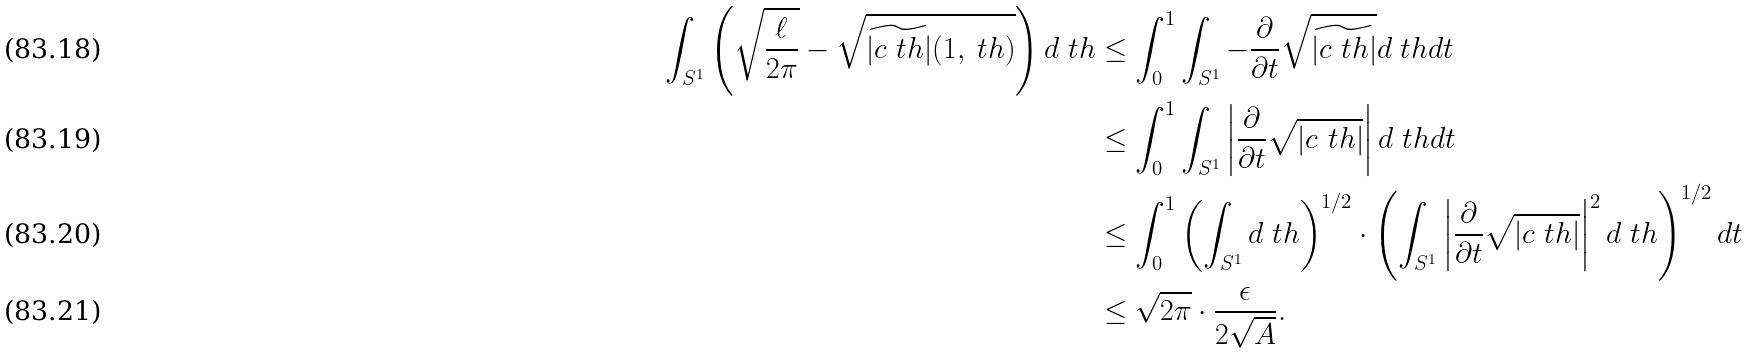Convert formula to latex. <formula><loc_0><loc_0><loc_500><loc_500>\int _ { S ^ { 1 } } \left ( \sqrt { \frac { \ell } { 2 \pi } } - \sqrt { \widetilde { | c _ { \ } t h | } ( 1 , \ t h ) } \right ) d \ t h & \leq \int _ { 0 } ^ { 1 } \int _ { S ^ { 1 } } - \frac { \partial } { \partial t } \sqrt { \widetilde { | c _ { \ } t h | } } d \ t h d t \\ & \leq \int _ { 0 } ^ { 1 } \int _ { S ^ { 1 } } \left | \frac { \partial } { \partial t } \sqrt { | c _ { \ } t h | } \right | d \ t h d t \\ & \leq \int _ { 0 } ^ { 1 } \left ( \int _ { S ^ { 1 } } d \ t h \right ) ^ { 1 / 2 } \cdot \left ( \int _ { S ^ { 1 } } \left | \frac { \partial } { \partial t } \sqrt { | c _ { \ } t h | } \right | ^ { 2 } d \ t h \right ) ^ { 1 / 2 } d t \\ & \leq \sqrt { 2 \pi } \cdot \frac { \epsilon } { 2 \sqrt { A } } .</formula> 